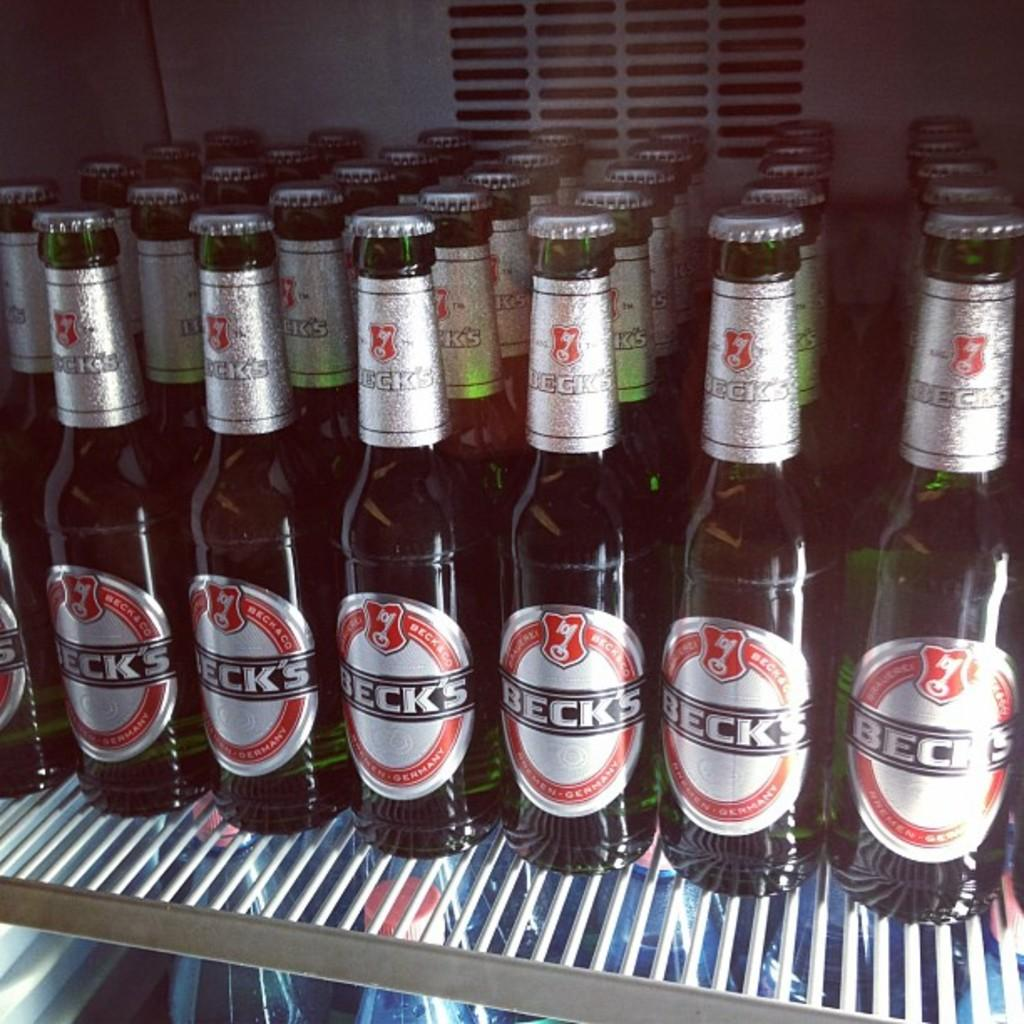Provide a one-sentence caption for the provided image. Bottles of Beck's beer is lined up on a refrigerator shelf. 